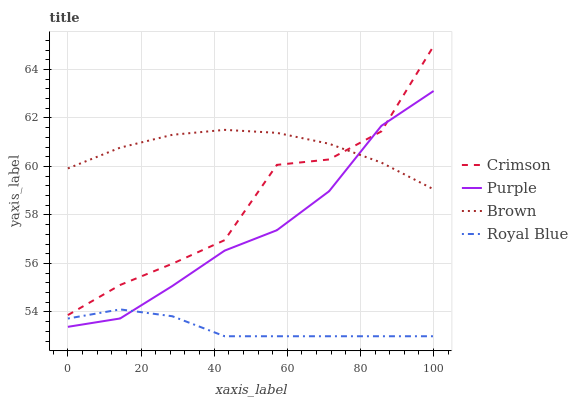Does Royal Blue have the minimum area under the curve?
Answer yes or no. Yes. Does Brown have the maximum area under the curve?
Answer yes or no. Yes. Does Purple have the minimum area under the curve?
Answer yes or no. No. Does Purple have the maximum area under the curve?
Answer yes or no. No. Is Brown the smoothest?
Answer yes or no. Yes. Is Crimson the roughest?
Answer yes or no. Yes. Is Purple the smoothest?
Answer yes or no. No. Is Purple the roughest?
Answer yes or no. No. Does Royal Blue have the lowest value?
Answer yes or no. Yes. Does Purple have the lowest value?
Answer yes or no. No. Does Crimson have the highest value?
Answer yes or no. Yes. Does Purple have the highest value?
Answer yes or no. No. Is Royal Blue less than Brown?
Answer yes or no. Yes. Is Crimson greater than Royal Blue?
Answer yes or no. Yes. Does Brown intersect Crimson?
Answer yes or no. Yes. Is Brown less than Crimson?
Answer yes or no. No. Is Brown greater than Crimson?
Answer yes or no. No. Does Royal Blue intersect Brown?
Answer yes or no. No. 